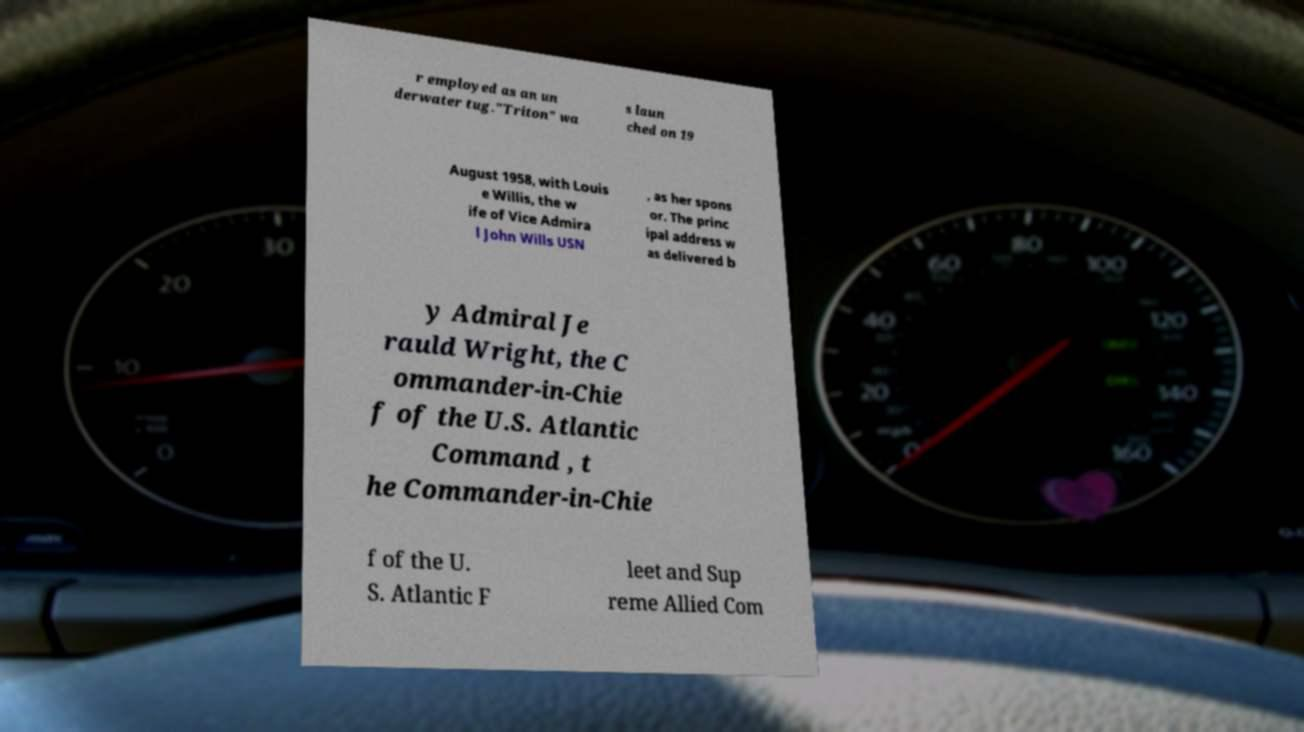Please identify and transcribe the text found in this image. r employed as an un derwater tug."Triton" wa s laun ched on 19 August 1958, with Louis e Willis, the w ife of Vice Admira l John Wills USN , as her spons or. The princ ipal address w as delivered b y Admiral Je rauld Wright, the C ommander-in-Chie f of the U.S. Atlantic Command , t he Commander-in-Chie f of the U. S. Atlantic F leet and Sup reme Allied Com 